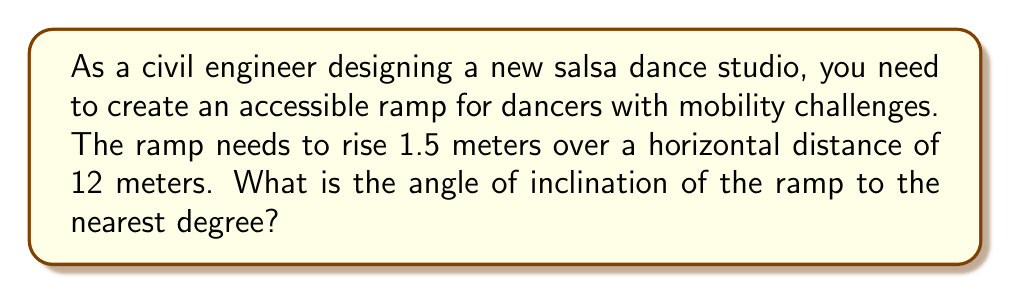Provide a solution to this math problem. Let's approach this step-by-step:

1) In this problem, we have a right triangle where:
   - The rise of the ramp is the opposite side (O) = 1.5 meters
   - The horizontal distance is the adjacent side (A) = 12 meters
   - The angle of inclination is what we're looking for

2) To find the angle, we can use the tangent function:

   $$\tan(\theta) = \frac{\text{Opposite}}{\text{Adjacent}} = \frac{O}{A}$$

3) Substituting our values:

   $$\tan(\theta) = \frac{1.5}{12}$$

4) To find θ, we need to use the inverse tangent (arctan or $\tan^{-1}$):

   $$\theta = \tan^{-1}(\frac{1.5}{12})$$

5) Using a calculator or computer:

   $$\theta \approx 7.125^\circ$$

6) Rounding to the nearest degree:

   $$\theta \approx 7^\circ$$

[asy]
unitsize(10mm);
draw((0,0)--(12,0)--(12,1.5)--(0,0));
draw((0,0)--(12,0),arrow=Arrow(TeXHead));
draw((12,0)--(12,1.5),arrow=Arrow(TeXHead));
label("12 m", (6,0), S);
label("1.5 m", (12,0.75), E);
label("$\theta$", (1,0.2), NW);
[/asy]
Answer: $7^\circ$ 